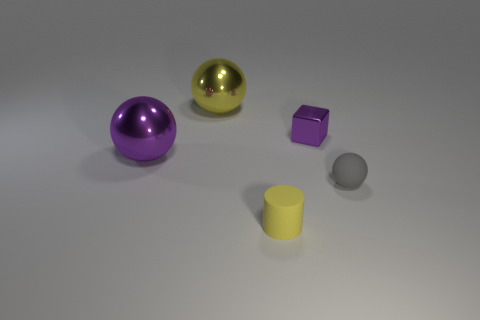Are there an equal number of tiny gray rubber balls to the left of the purple ball and spheres to the left of the tiny yellow object?
Your answer should be compact. No. How many tiny brown objects have the same material as the gray object?
Provide a short and direct response. 0. There is a large shiny thing that is the same color as the tiny metallic object; what is its shape?
Offer a very short reply. Sphere. There is a purple shiny ball that is in front of the yellow object that is behind the rubber ball; what size is it?
Ensure brevity in your answer.  Large. Do the yellow thing behind the gray thing and the purple metallic thing left of the yellow rubber object have the same shape?
Make the answer very short. Yes. Are there the same number of tiny gray objects right of the tiny purple shiny thing and purple blocks?
Offer a terse response. Yes. What is the color of the rubber object that is the same shape as the large yellow shiny thing?
Offer a very short reply. Gray. Is the material of the purple object that is to the left of the tiny matte cylinder the same as the big yellow thing?
Give a very brief answer. Yes. What number of tiny things are blue balls or yellow shiny things?
Ensure brevity in your answer.  0. The yellow sphere has what size?
Make the answer very short. Large. 